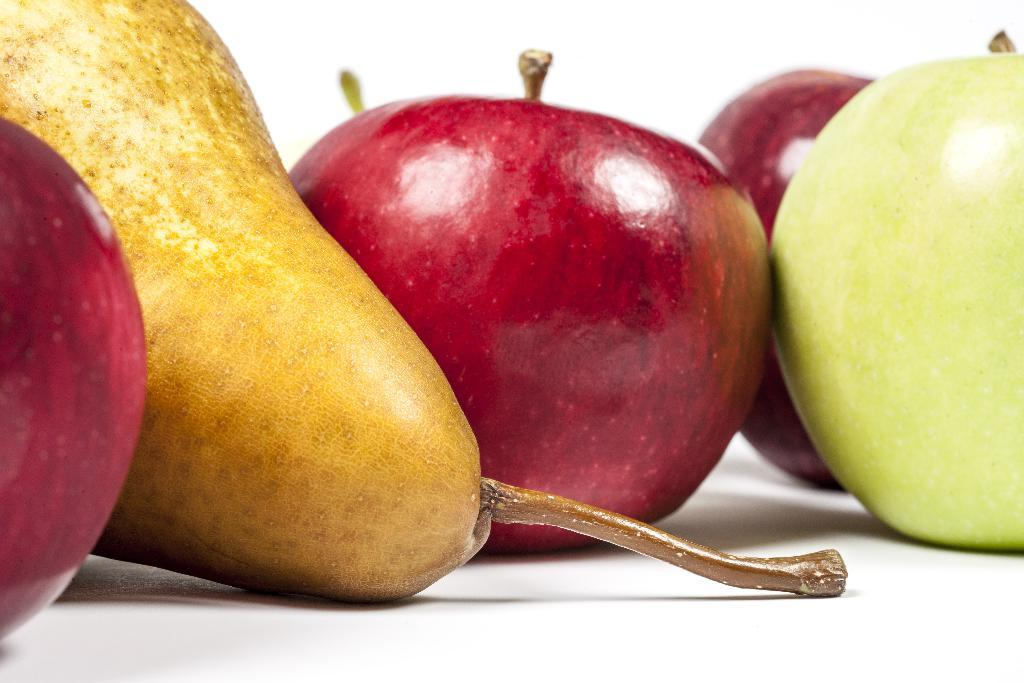What type of fruit can be seen in the image? There are red apples, a green apple, and a pear in the image. What is the color of the green apple? The green apple is green in color. What is the color of the background in the image? The background appears to be white in color. What can be seen connecting the fruit to the stem? There is a stem visible in the image. What does the dad say about the powder in the image? There is no dad or powder present in the image, so this question cannot be answered. 